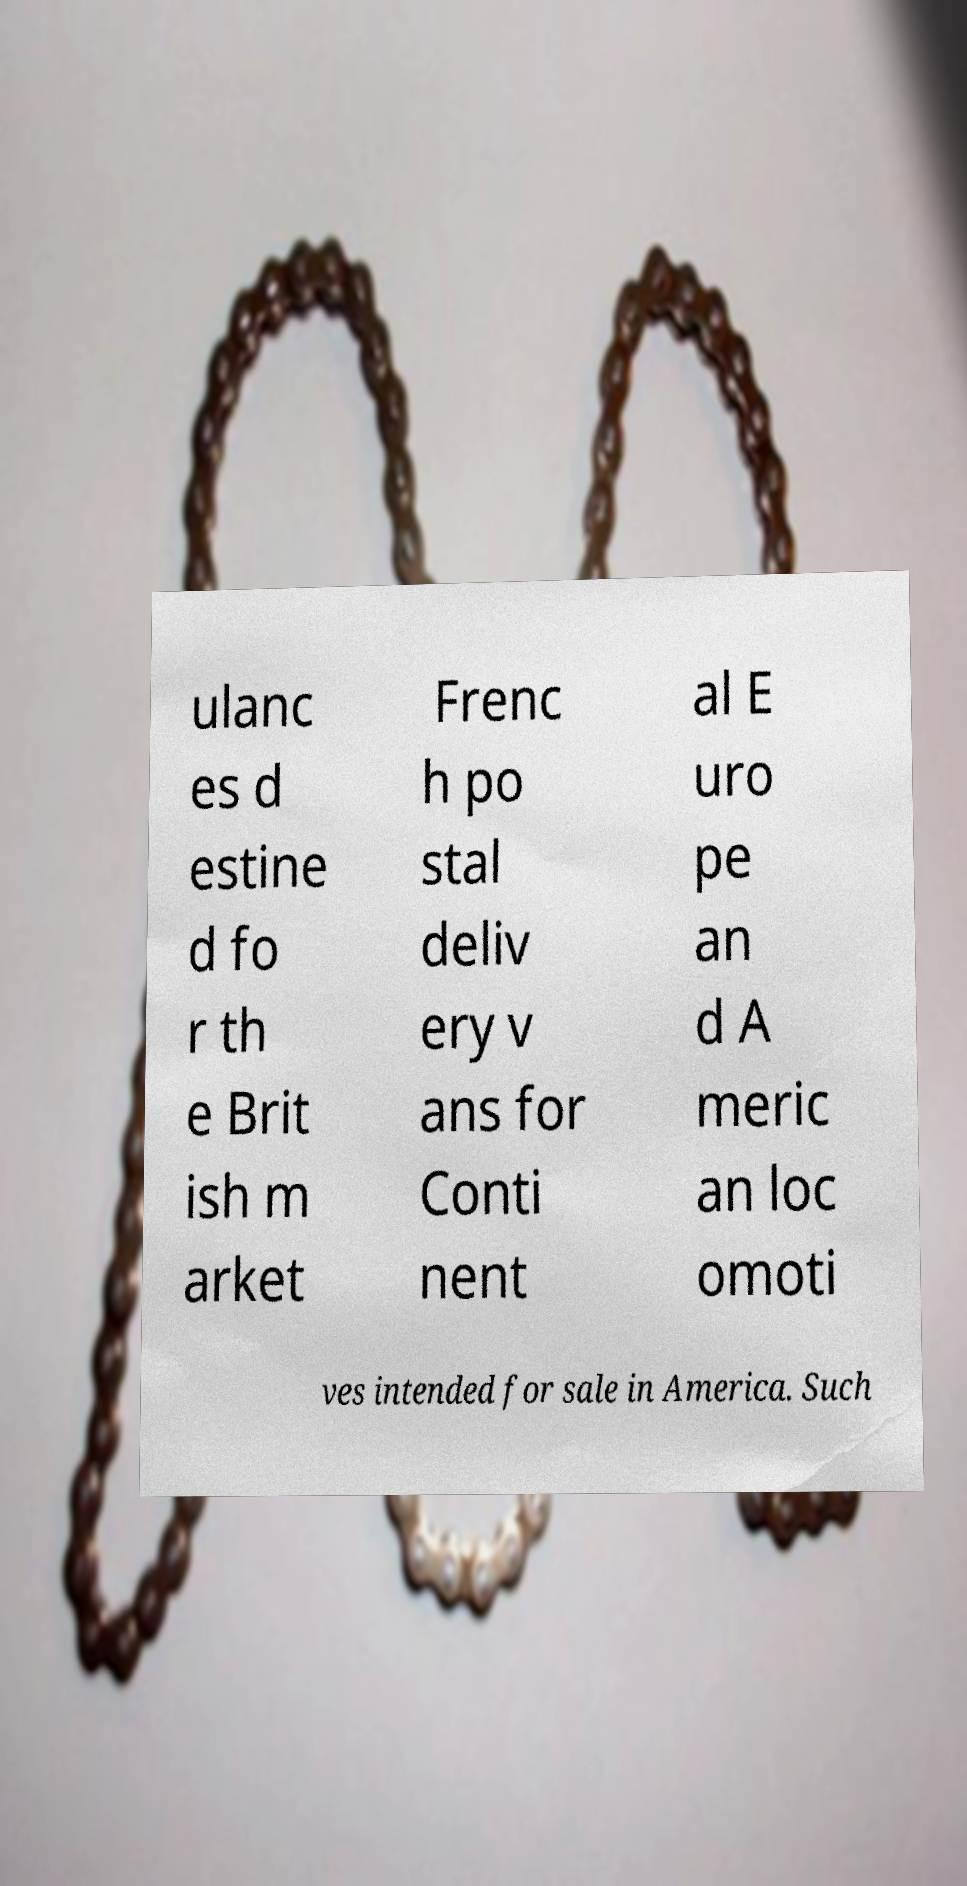Could you assist in decoding the text presented in this image and type it out clearly? ulanc es d estine d fo r th e Brit ish m arket Frenc h po stal deliv ery v ans for Conti nent al E uro pe an d A meric an loc omoti ves intended for sale in America. Such 